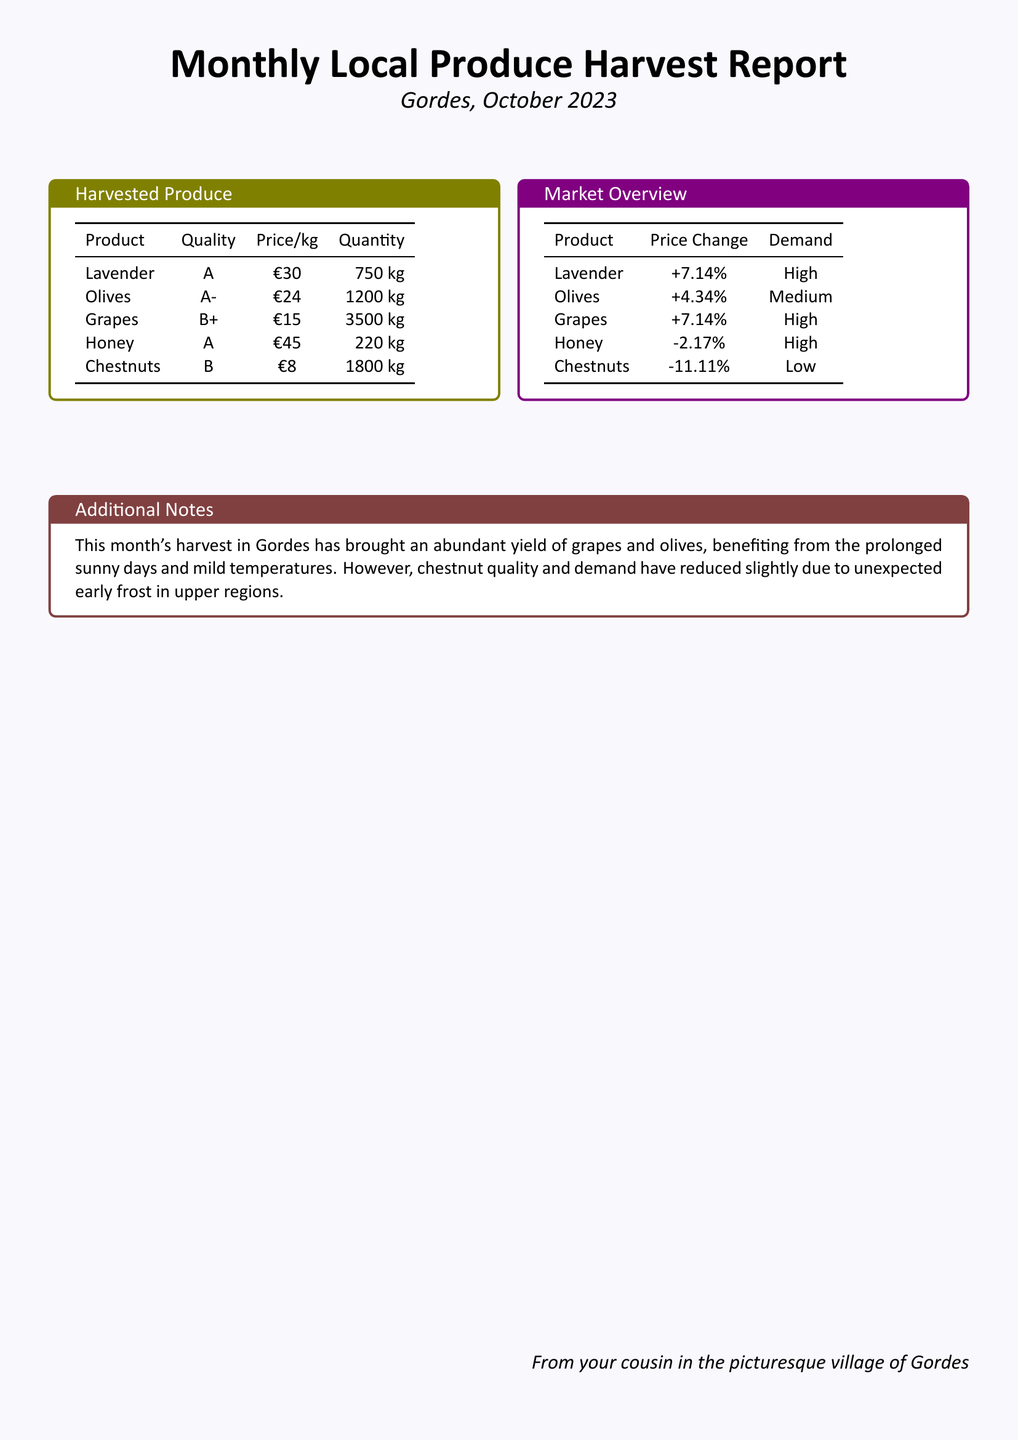what is the total quantity of grapes harvested? The total quantity of grapes harvested can be found in the Harvested Produce table, which lists grapes at 3500 kg.
Answer: 3500 kg what is the quality rating of olives? The quality rating of olives is found in the Harvested Produce table, which shows olives rated A-.
Answer: A- what is the price per kilogram of honey? The price per kilogram of honey is listed in the Harvested Produce table as €45.
Answer: €45 which product had the highest price change? The product with the highest price change is found in the Market Overview table, where lavender and grapes both increased by +7.14%.
Answer: Lavender and Grapes what was the demand for chestnuts? The demand for chestnuts is noted in the Market Overview table, where it is indicated as low.
Answer: Low how much did chestnut prices change? Chestnut prices changed by -11.11%, as shown in the Market Overview table.
Answer: -11.11% what quantity of honey was harvested? The quantity of honey harvested can be retrieved from the Harvested Produce table, which states 220 kg.
Answer: 220 kg what is the overall quality of lavender? The overall quality of lavender is indicated in the Harvested Produce table as A.
Answer: A what caused the reduced quality and demand for chestnuts? The Additional Notes section mentions unexpected early frost in upper regions as the cause for reduced quality and demand for chestnuts.
Answer: Unexpected early frost 